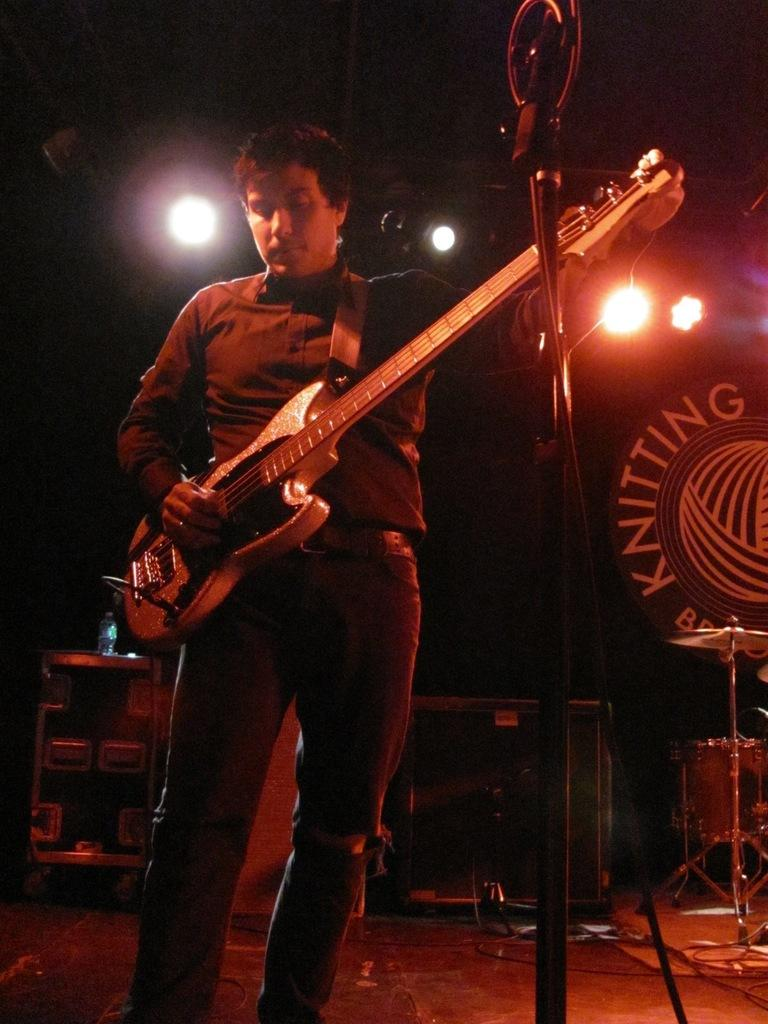What is the person in the image doing? The person is standing in the image and holding a guitar in their hand. Where is the person standing? The person is standing on the floor. What is in front of the person? There is a stand in front of the person. What can be seen above the person? There are lights visible above the person. What type of wound can be seen on the person's hand in the image? There is no wound visible on the person's hand in the image. What kind of coil is wrapped around the guitar in the image? There is no coil wrapped around the guitar in the image. 